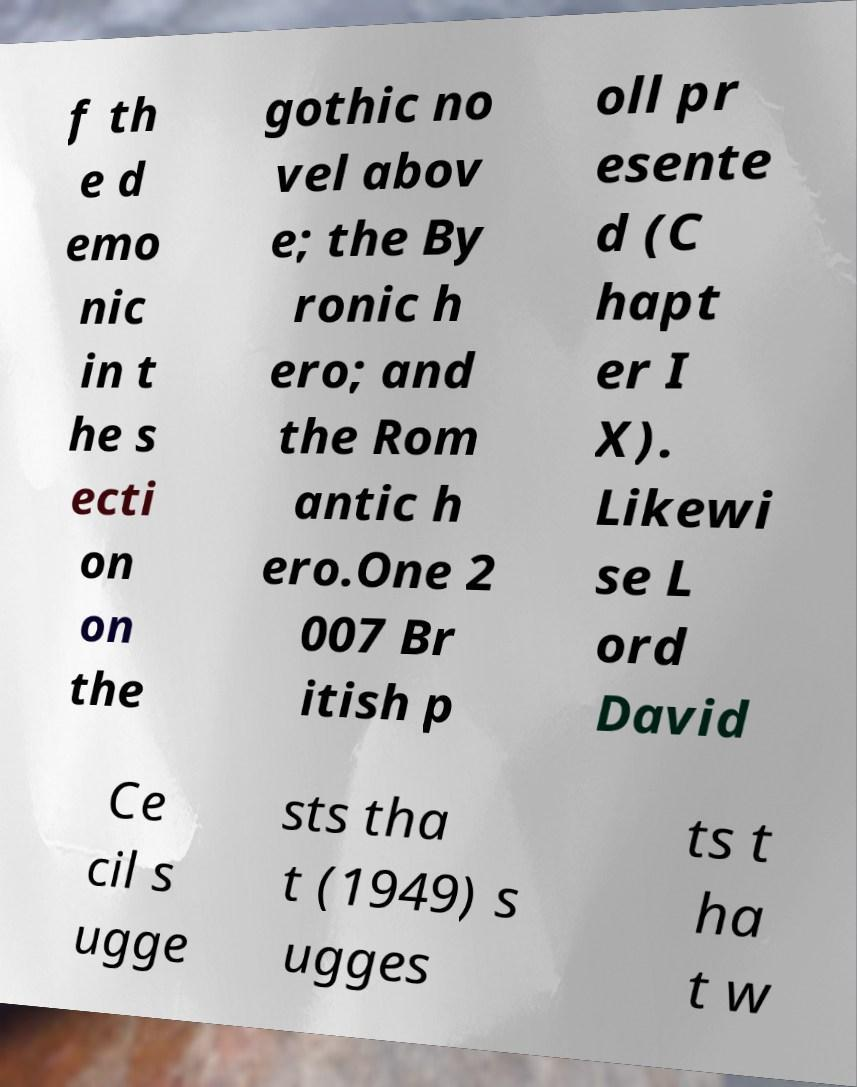There's text embedded in this image that I need extracted. Can you transcribe it verbatim? f th e d emo nic in t he s ecti on on the gothic no vel abov e; the By ronic h ero; and the Rom antic h ero.One 2 007 Br itish p oll pr esente d (C hapt er I X). Likewi se L ord David Ce cil s ugge sts tha t (1949) s ugges ts t ha t w 